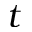<formula> <loc_0><loc_0><loc_500><loc_500>t</formula> 